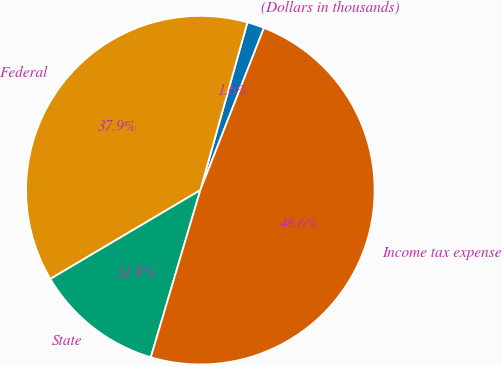<chart> <loc_0><loc_0><loc_500><loc_500><pie_chart><fcel>(Dollars in thousands)<fcel>Federal<fcel>State<fcel>Income tax expense<nl><fcel>1.59%<fcel>37.86%<fcel>11.91%<fcel>48.64%<nl></chart> 